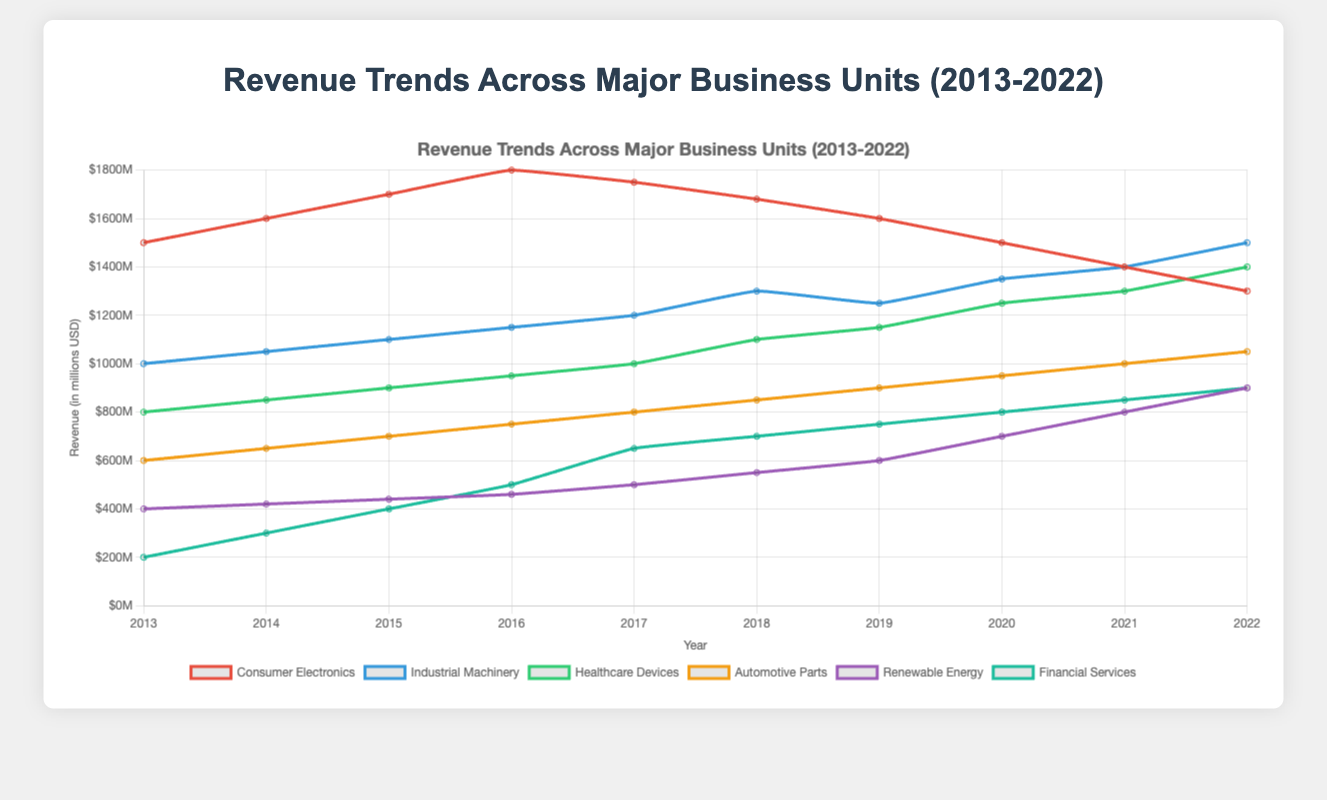What is the revenue trend for Consumer Electronics from 2013 to 2022? The revenues for Consumer Electronics start at $1500M in 2013 and rise to $1800M in 2016. Then, there is a decline every year, reaching $1300M in 2022.
Answer: Declining after 2016 Which business unit had the highest revenue in 2022? In 2022, Industrial Machinery had the highest revenue among all business units with $1500M.
Answer: Industrial Machinery By how much did the revenue for Renewable Energy increase from 2013 to 2022? The revenue for Renewable Energy in 2013 was $400M and increased to $900M in 2022. The difference is $900M - $400M = $500M.
Answer: $500M What is the average revenue for Financial Services between 2013 and 2022? The revenues for Financial Services from 2013 to 2022 are [200, 300, 400, 500, 650, 700, 750, 800, 850, 900]. The sum is 6050, and the average is 6050/10 = 605.
Answer: $605M Did Healthcare Devices or Automotive Parts see a greater increase in revenue over the decade? Healthcare Devices increased from $800M to $1400M, which is a $600M increase. Automotive Parts increased from $600M to $1050M, which is a $450M increase. Healthcare Devices saw a greater increase.
Answer: Healthcare Devices Which business unit showed the most consistent growth without any decline from 2013 to 2022? Financial Services showed consistent growth every year from $200M in 2013 to $900M in 2022, without any decline.
Answer: Financial Services In which year did Industrial Machinery surpass Consumer Electronics in revenue? Industrial Machinery surpassed Consumer Electronics in revenue in 2021, with $1400M for Industrial Machinery compared to $1400M for Consumer Electronics.
Answer: 2021 How much did the revenue for Consumer Electronics decrease from its peak in 2016 to 2022? The revenue for Consumer Electronics peaked at $1800M in 2016 and decreased to $1300M in 2022. The decrease is $1800M - $1300M = $500M.
Answer: $500M Which business unit had the least amount of growth over the decade? Consumer Electronics had the least growth, with a decrease from $1500M in 2013 to $1300M in 2022.
Answer: Consumer Electronics 